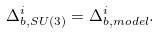<formula> <loc_0><loc_0><loc_500><loc_500>\Delta _ { b , S U ( 3 ) } ^ { i } = \Delta _ { b , m o d e l } ^ { i } \/ .</formula> 